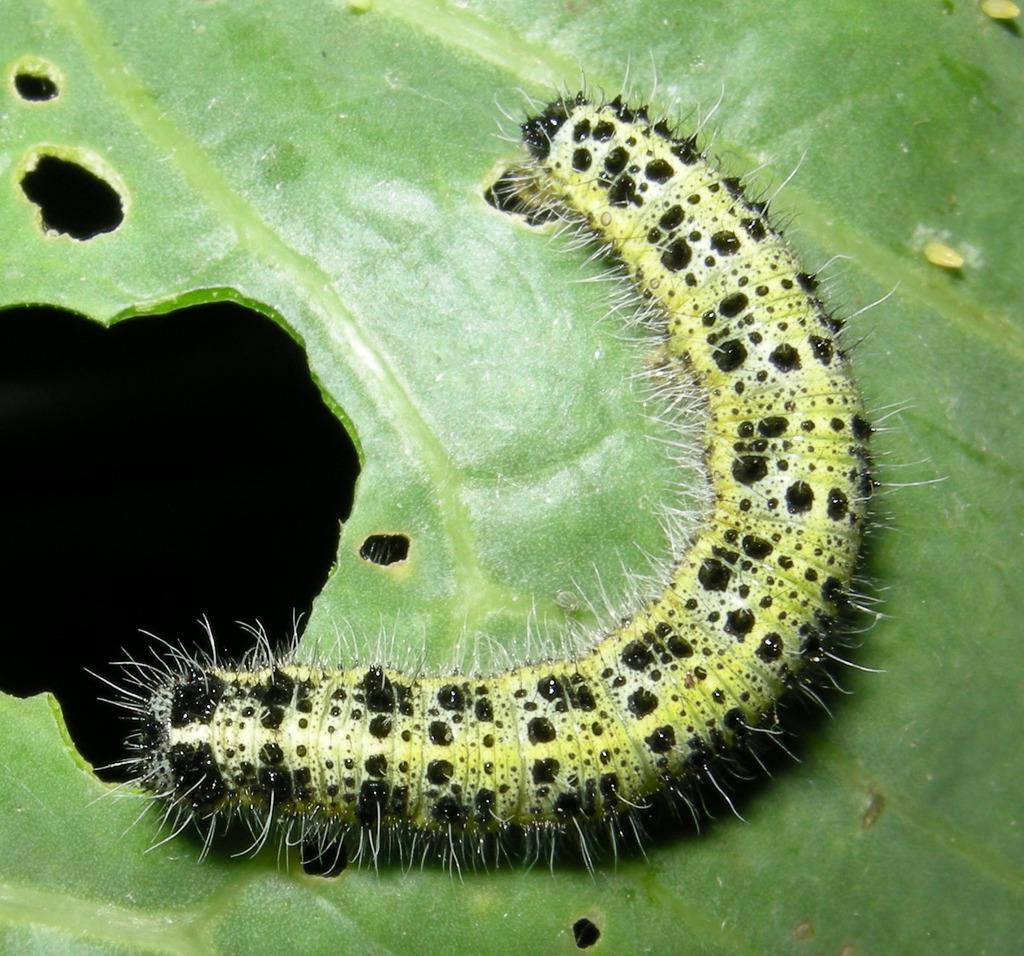What is present on the leaf in the image? There is an insect on the leaf in the image. Can you describe the insect's location on the leaf? The insect is on the leaf in the image. What type of property is visible in the background of the image? There is no property visible in the image; it only features an insect on a leaf. 